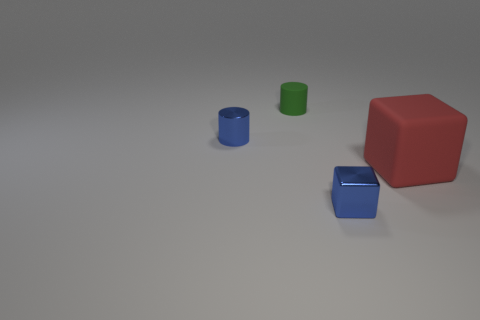Add 4 yellow metal blocks. How many objects exist? 8 Subtract all large cubes. Subtract all red objects. How many objects are left? 2 Add 2 large red cubes. How many large red cubes are left? 3 Add 2 big cyan matte objects. How many big cyan matte objects exist? 2 Subtract 0 gray cylinders. How many objects are left? 4 